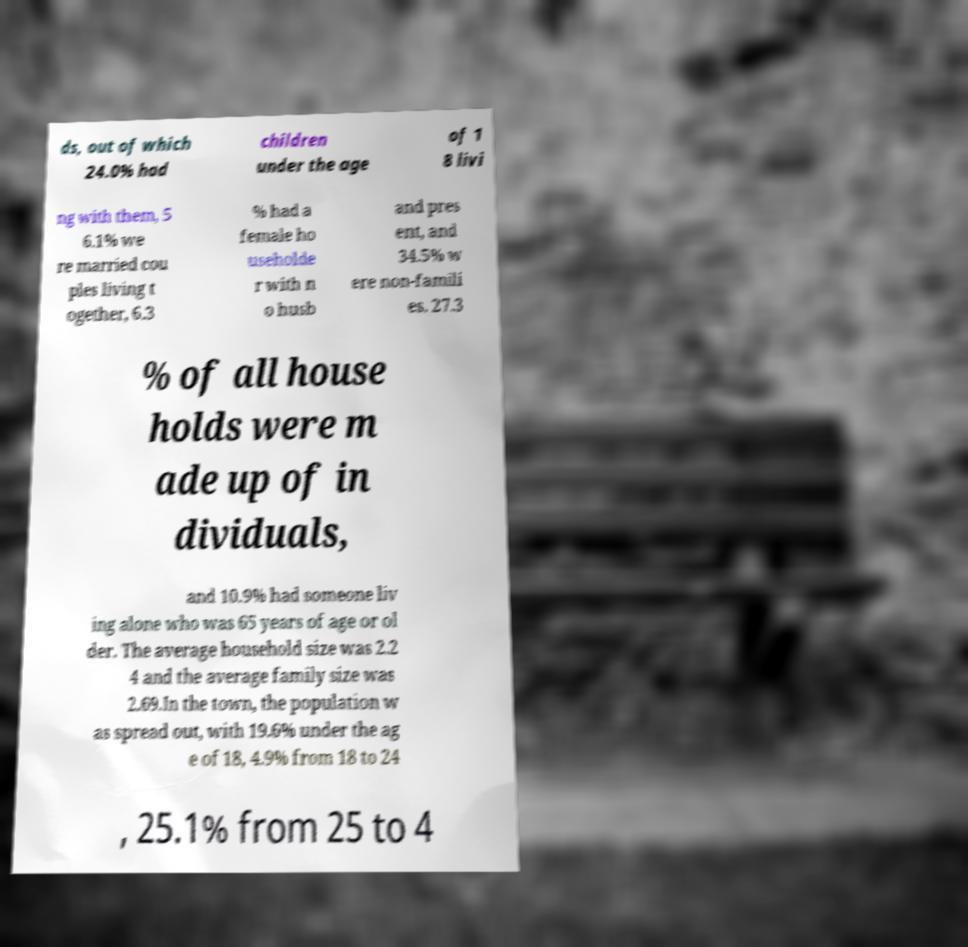Can you read and provide the text displayed in the image?This photo seems to have some interesting text. Can you extract and type it out for me? ds, out of which 24.0% had children under the age of 1 8 livi ng with them, 5 6.1% we re married cou ples living t ogether, 6.3 % had a female ho useholde r with n o husb and pres ent, and 34.5% w ere non-famili es. 27.3 % of all house holds were m ade up of in dividuals, and 10.9% had someone liv ing alone who was 65 years of age or ol der. The average household size was 2.2 4 and the average family size was 2.69.In the town, the population w as spread out, with 19.6% under the ag e of 18, 4.9% from 18 to 24 , 25.1% from 25 to 4 